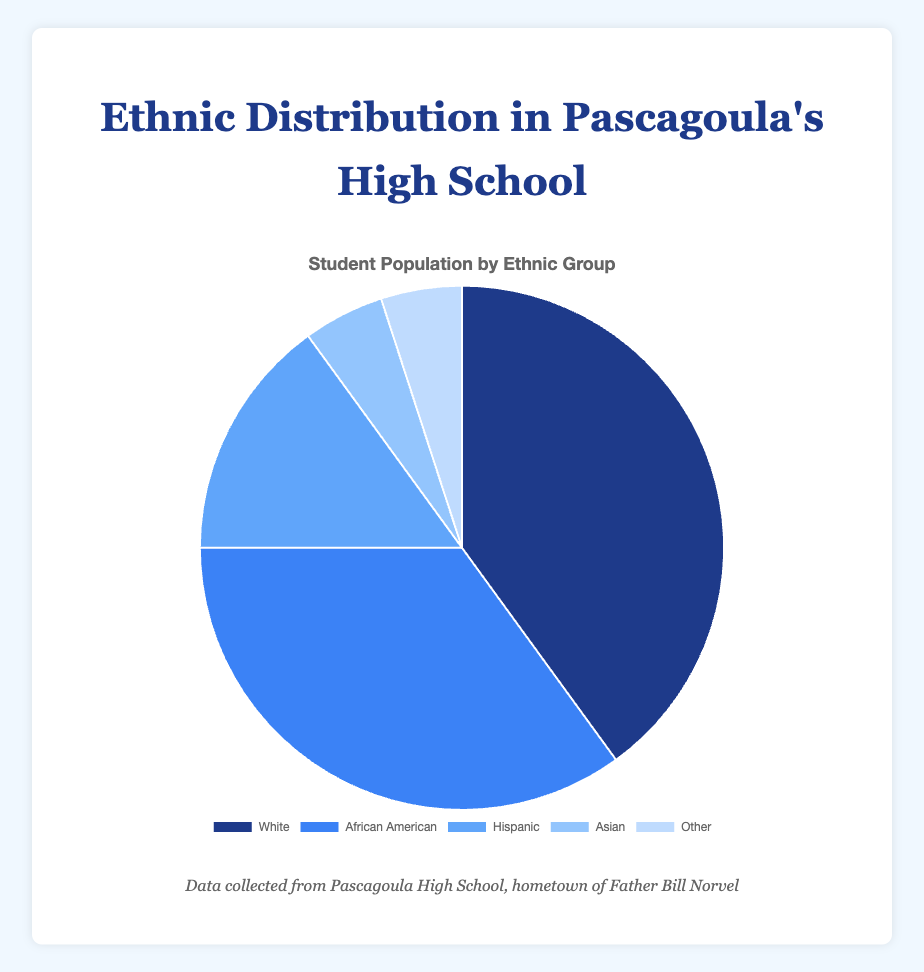What is the most represented ethnic group among Pascagoula High School students? To identify the most represented ethnic group, look at the pie chart slices and their corresponding percentages. The largest slice represents the ethnic group with the highest percentage, which is "White" at 40%.
Answer: White Which two ethnic groups together make up 50% of the student population? To determine which two groups together make up 50%, sum their percentages. The "Hispanic" and "Asian" groups each have 15% and 5%, respectively, for a total of 20%. Adding "Other" group's 5% results in 25%. Adding "African American" at 35% and "White" at 40% exceeds 50%. Thus, “White” at 40% and “Hispanic” at 15% add up to 55%, and the answer is "African American" and "Hispanic", totaling 35% + 15% = 50%
Answer: African American and Hispanic What is the difference in the percentage of the student population between the largest and smallest ethnic groups? To find the difference between the largest and smallest ethnic groups, subtract the smallest percentage (5% for "Asian" and "Other") from the largest percentage (40% for "White"). 40% - 5% = 35%.
Answer: 35% Which ethnic group(s) constitute exactly 5% of Pascagoula High School's student population? Look for the pie chart slices with the label 5%. Both "Asian" and "Other" categories fit this description.
Answer: Asian and Other How does the percentage of Hispanic students compare to the percentage of African American students? Compare their percentages directly. The percentage of "Hispanic" students is 15%, while the percentage of "African American" students is 35%. The "Hispanic" percentage is 20% less than the "African American" percentage.
Answer: Hispanic has 20% less than African American If the student body consists of 1,000 students, approximately how many students belong to the Asian ethnic group? Calculate 5% of 1,000. \(0.05 \times 1000 = 50\).
Answer: 50 What percentage of students belong to ethnic groups other than White and African American? Add the percentages of the ethnic groups that are neither "White" nor "African American": Hispanic (15%), Asian (5%), and Other (5%). \(15% + 5% + 5% = 25%\).
Answer: 25% How many more percentages do African American and Hispanic groups together represent compared to the Asian and Other groups combined? First sum the percentages: African American (35%) + Hispanic (15%) = 50%. Then, Asian (5%) + Other (5%) = 10%. Subtract the smaller from the larger: \(50% - 10% = 40%\).
Answer: 40% What proportion of the student population is either White or Asian? Add the percentages for "White" and "Asian": \(40% + 5% = 45%\).
Answer: 45% 